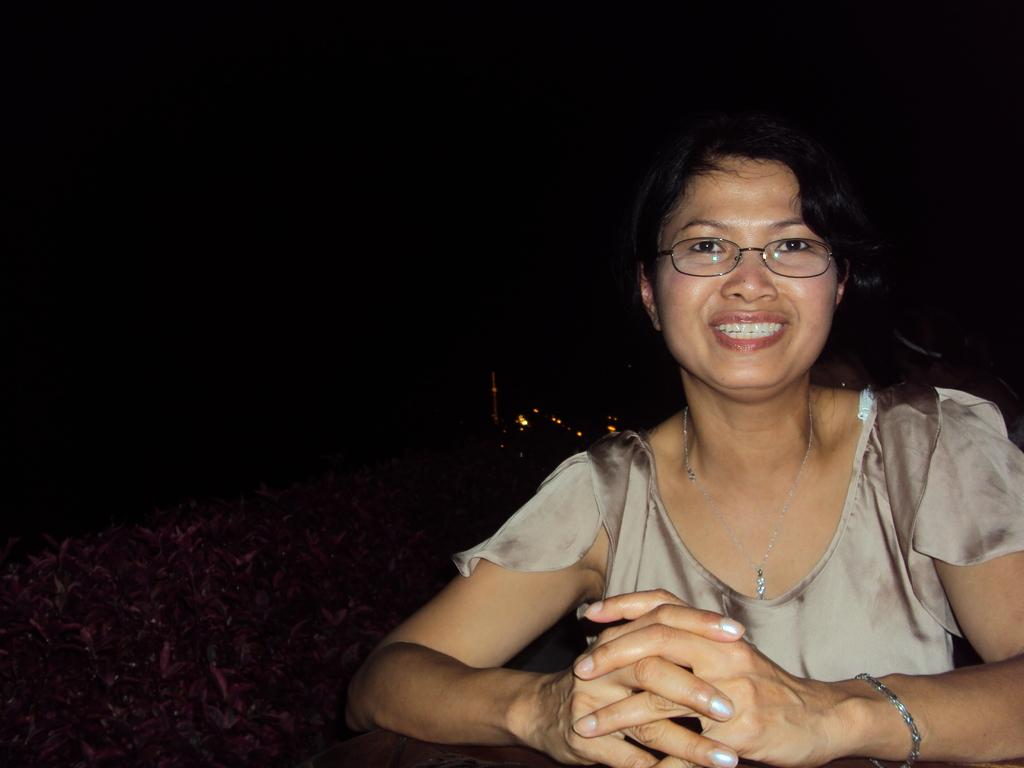Who is the main subject in the image? There is a lady in the image. What accessories is the lady wearing? The lady is wearing specs, a chain, and a bracelet. What is the lady's facial expression in the image? The lady is smiling in the image. What can be seen near the lady? There are plants near the lady. How would you describe the background of the image? The background of the image is dark. Can you tell me how many copies of the sun are visible in the image? There are no copies of the sun visible in the image, as the background is dark and no celestial bodies are present. 